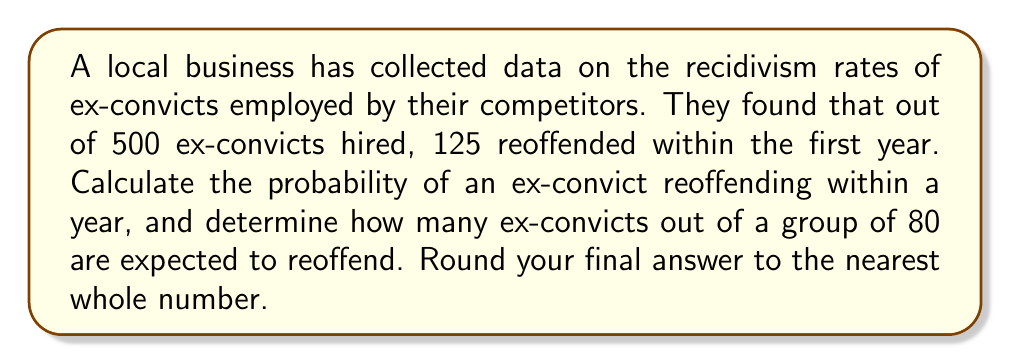Can you solve this math problem? To solve this problem, we need to follow these steps:

1. Calculate the probability of recidivism:
   Let $p$ be the probability of an ex-convict reoffending within a year.
   $$p = \frac{\text{Number of ex-convicts who reoffended}}{\text{Total number of ex-convicts hired}}$$
   $$p = \frac{125}{500} = 0.25 = 25\%$$

2. Calculate the expected number of ex-convicts to reoffend in a group of 80:
   We can use the expected value formula, where $n$ is the number of ex-convicts and $p$ is the probability of reoffending.
   $$E(\text{reoffenders}) = n \cdot p$$
   $$E(\text{reoffenders}) = 80 \cdot 0.25 = 20$$

3. Round the result to the nearest whole number:
   The expected number of reoffenders is already a whole number, so no rounding is necessary.
Answer: 20 ex-convicts 